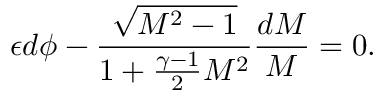Convert formula to latex. <formula><loc_0><loc_0><loc_500><loc_500>\epsilon d \phi - \frac { \sqrt { M ^ { 2 } - 1 } } { 1 + \frac { \gamma - 1 } { 2 } M ^ { 2 } } \frac { d M } { M } = 0 .</formula> 